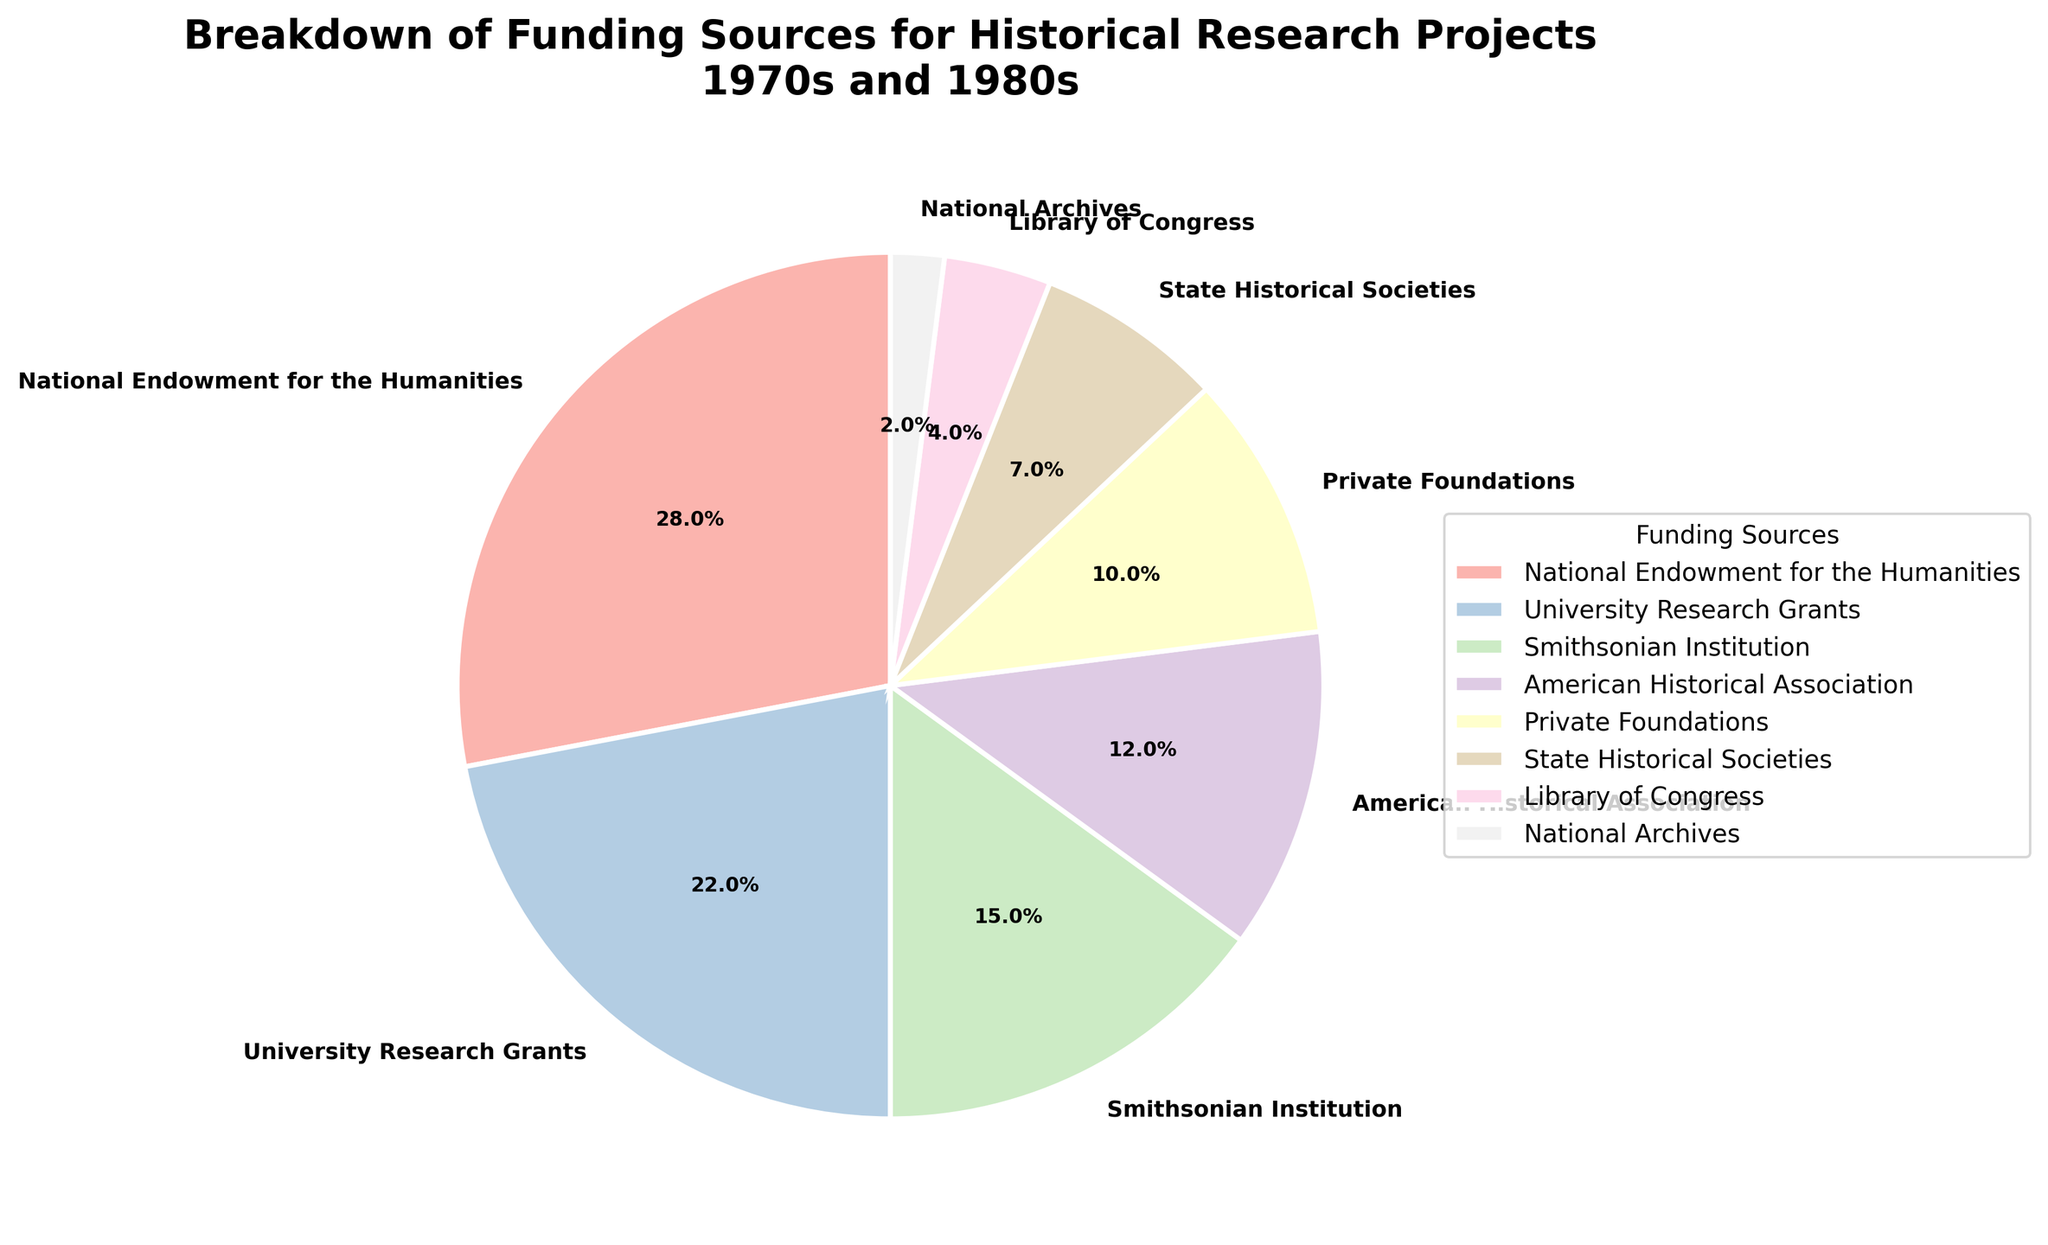Which funding source contributed the most to historical research projects in the 1970s and 1980s? The largest section of the pie chart represents the National Endowment for the Humanities, which has the highest percentage.
Answer: National Endowment for the Humanities What is the percentage difference between University Research Grants and Smithsonian Institution funding? University Research Grants contributed 22%, while the Smithsonian Institution contributed 15%. The difference is 22% - 15%.
Answer: 7% What fraction of the total funding is provided by the American Historical Association and Private Foundations combined? The percentage for American Historical Association is 12% and for Private Foundations is 10%. The combined percentage is 12% + 10%.
Answer: 22% Which funding source contributed the least to historical research projects in the 1970s and 1980s? The smallest section of the pie chart represents the National Archives, which has the lowest percentage.
Answer: National Archives Calculate the average percentage of funding provided by State Historical Societies and Library of Congress. The percentages are 7% and 4% respectively. The average is (7% + 4%) / 2.
Answer: 5.5% Did Private Foundations contribute less or more funding than the Smithsonian Institution? Private Foundations contributed 10%, whereas the Smithsonian Institution contributed 15%. 10% is less than 15%.
Answer: less How many funding sources contributed 10% or more to the historical research projects? The segments contributing 10% or more are from National Endowment for the Humanities (28%), University Research Grants (22%), Smithsonian Institution (15%), American Historical Association (12%), and Private Foundations (10%). This counts to 5 segments.
Answer: 5 By how much does the percentage of Library of Congress funding differ from State Historical Societies? Library of Congress funding is 4% and State Historical Societies funding is 7%. The difference is 7% - 4%.
Answer: 3% 